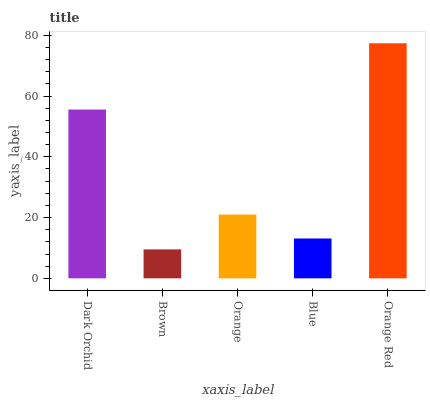Is Brown the minimum?
Answer yes or no. Yes. Is Orange Red the maximum?
Answer yes or no. Yes. Is Orange the minimum?
Answer yes or no. No. Is Orange the maximum?
Answer yes or no. No. Is Orange greater than Brown?
Answer yes or no. Yes. Is Brown less than Orange?
Answer yes or no. Yes. Is Brown greater than Orange?
Answer yes or no. No. Is Orange less than Brown?
Answer yes or no. No. Is Orange the high median?
Answer yes or no. Yes. Is Orange the low median?
Answer yes or no. Yes. Is Orange Red the high median?
Answer yes or no. No. Is Dark Orchid the low median?
Answer yes or no. No. 